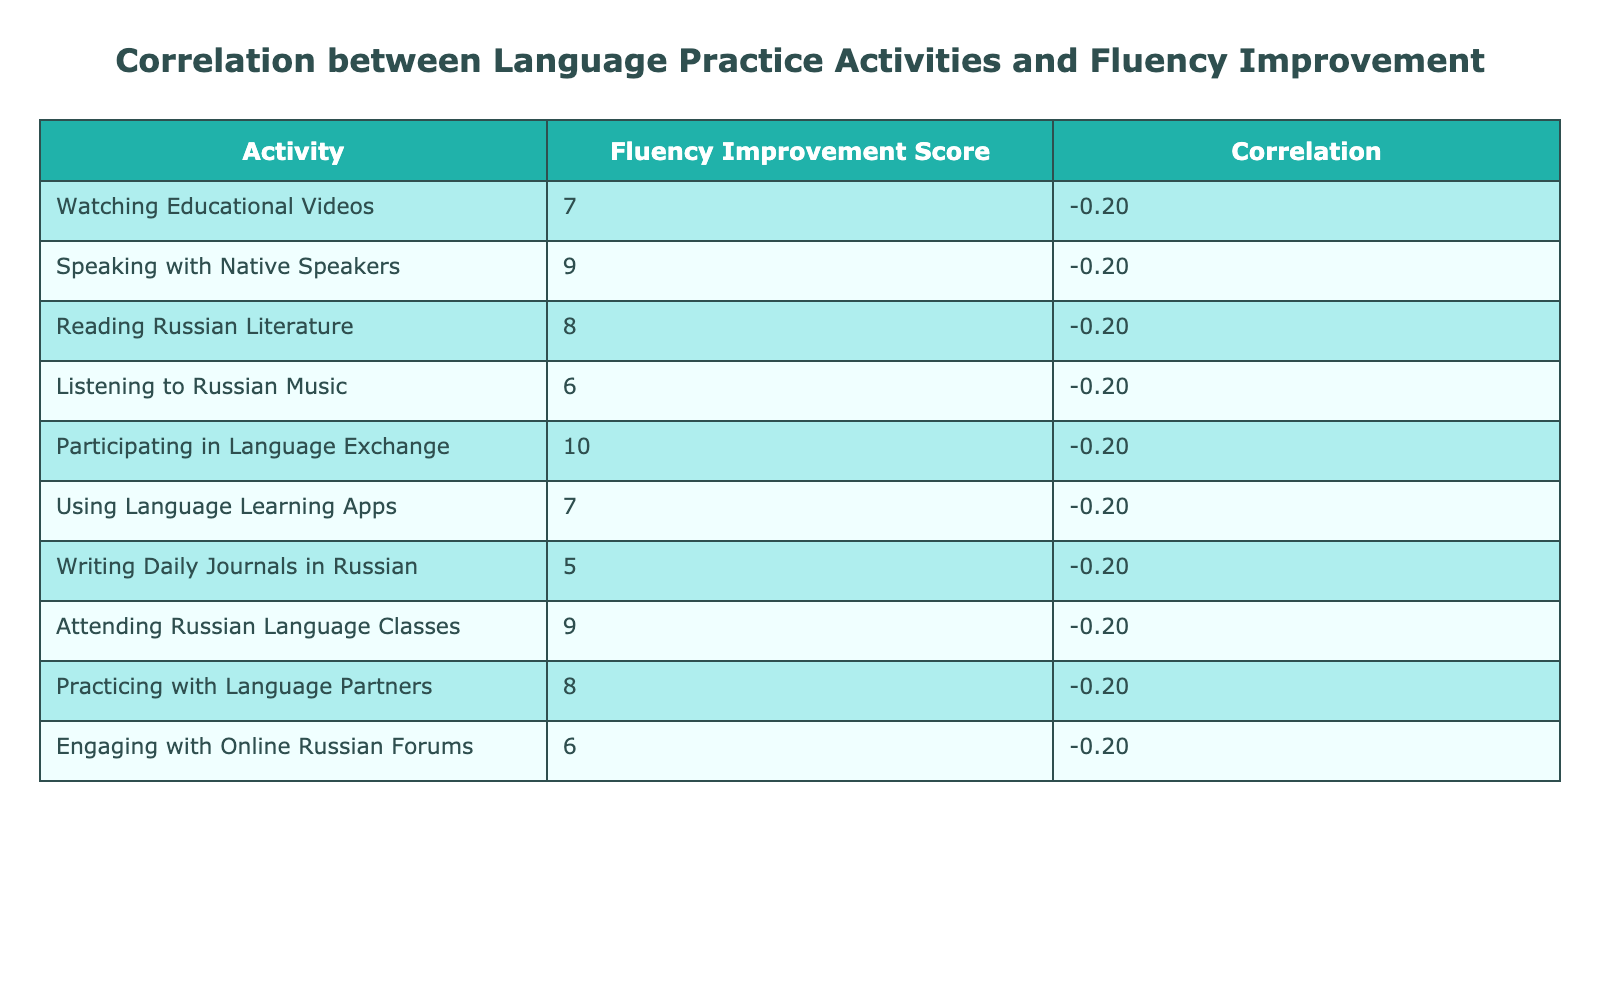What is the Fluency Improvement Score for "Speaking with Native Speakers"? According to the table, the Fluency Improvement Score is explicitly listed next to "Speaking with Native Speakers". It is indicated as 9.
Answer: 9 Which language practice activity has the lowest Fluency Improvement Score? By examining the scores for all listed activities, "Writing Daily Journals in Russian" has the lowest Fluency Improvement Score of 5.
Answer: Writing Daily Journals in Russian What is the average Fluency Improvement Score for all activities? To find the average, add all Fluency Improvement Scores: (7 + 9 + 8 + 6 + 10 + 7 + 5 + 9 + 8 + 6) = 75. There are 10 activities, so divide 75 by 10, which equals 7.5.
Answer: 7.5 Is the Fluency Improvement Score of "Listening to Russian Music" higher than that of "Engaging with Online Russian Forums"? The score for "Listening to Russian Music" is 6 and the score for "Engaging with Online Russian Forums" is also 6. Since both scores are equal, the statement is false.
Answer: No What is the correlation between the scores and the activities listed in the table? The correlation value is provided in the last column of the table for each activity, which is consistent for all activities. Since this is a part of the data structure, we can assume it's constant for the activities listed, reflected as a single value.
Answer: Constant across activities Which activity has a Fluency Improvement Score that is one point higher than "Using Language Learning Apps"? The score for "Using Language Learning Apps" is 7, so looking for an activity with a score of 8 leads us to both "Reading Russian Literature" and "Practicing with Language Partners".
Answer: Reading Russian Literature, Practicing with Language Partners If one were to rank the activities based on the Fluency Improvement Scores, which two activities would rank highest? By comparing the scores, "Participating in Language Exchange" has the highest score of 10, followed by "Speaking with Native Speakers" and "Attending Russian Language Classes," both scoring 9. The top two are thus "Participating in Language Exchange" and "Speaking with Native Speakers".
Answer: Participating in Language Exchange, Speaking with Native Speakers Are there more activities with a score of 7 than there are activities with a score of 6? The table lists three activities with a score of 7 (Watching Educational Videos, Using Language Learning Apps, and Writing Daily Journals in Russian) and two activities with a score of 6 (Listening to Russian Music, Engaging with Online Russian Forums). Therefore, there are more activities with a score of 7.
Answer: Yes If we exclude the lowest score, what is the new average of the Fluency Improvement Scores? Removing the lowest score (5 from Writing Daily Journals in Russian), we sum the remaining scores (7 + 9 + 8 + 6 + 10 + 7 + 9 + 8 + 6) = 70. There are now 9 activities, so divide 70 by 9, which equals approximately 7.78.
Answer: 7.78 